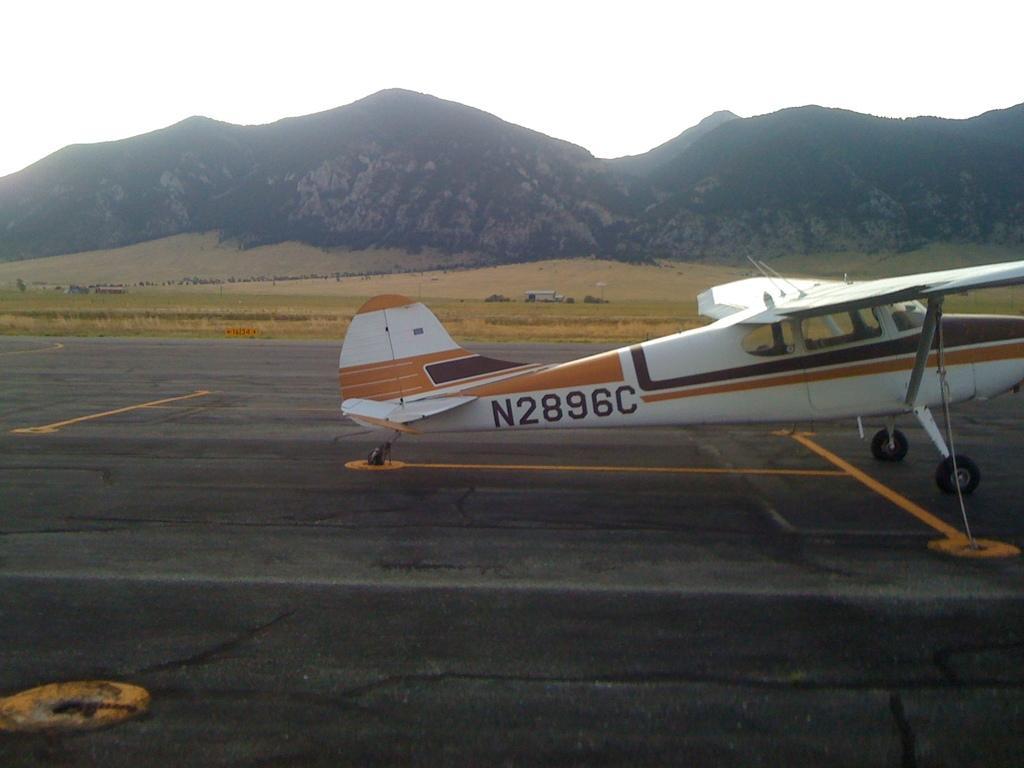Can you describe this image briefly? In this image i can see the aircraft, the road, grass, hills, i can see the sky. 